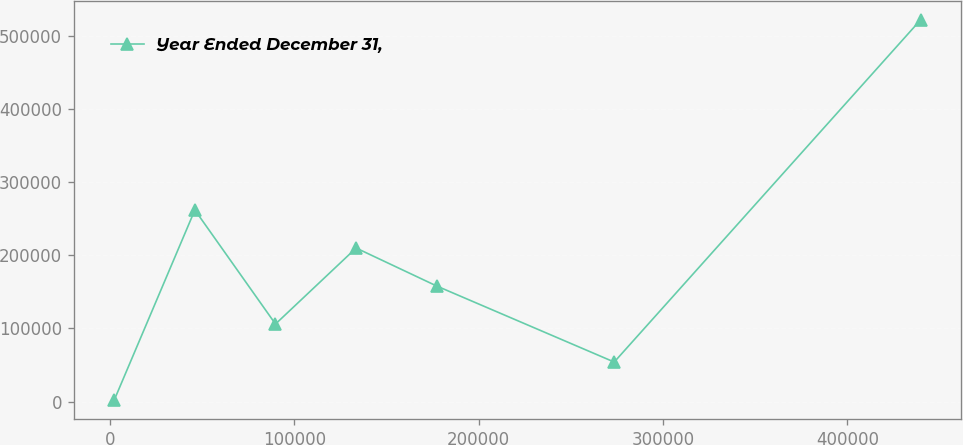Convert chart. <chart><loc_0><loc_0><loc_500><loc_500><line_chart><ecel><fcel>Year Ended December 31,<nl><fcel>2261.56<fcel>2067.6<nl><fcel>46007.4<fcel>261997<nl><fcel>89753.3<fcel>106039<nl><fcel>133499<fcel>210011<nl><fcel>177245<fcel>158025<nl><fcel>273534<fcel>54053.4<nl><fcel>439720<fcel>521926<nl></chart> 